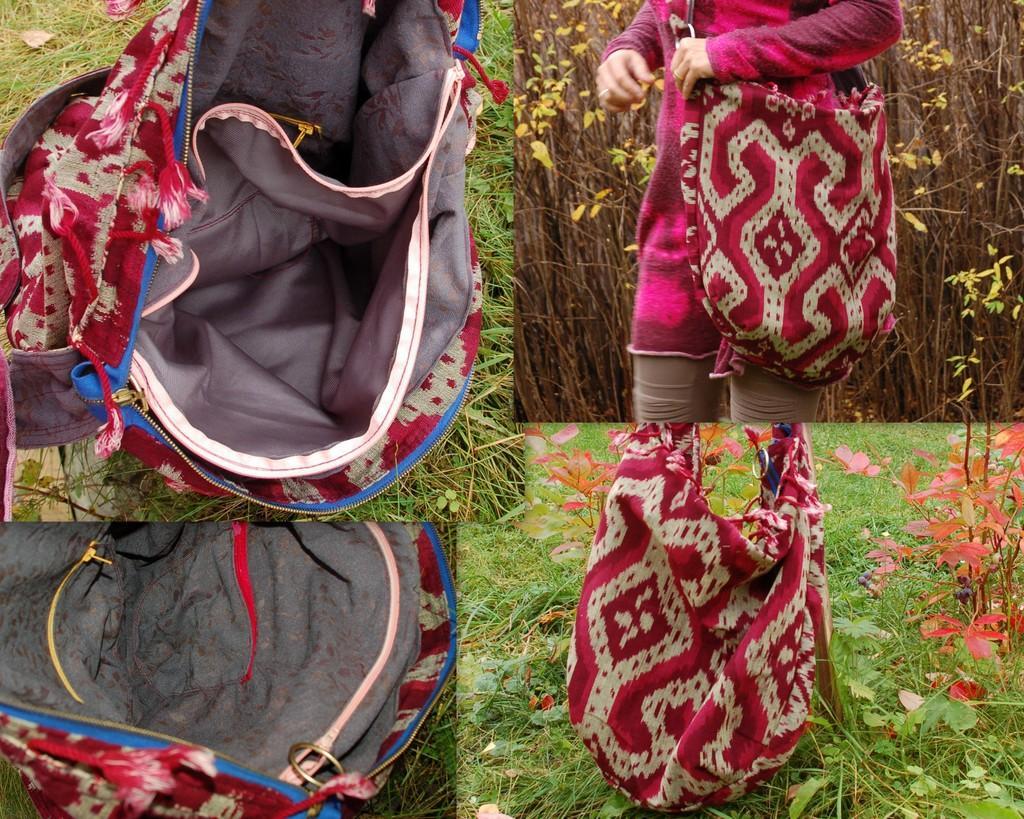Could you give a brief overview of what you see in this image? This is a collage image and in the right side we can see a person having a handbag and at the bottom right we can see only handbag placed on grass and at the top left we can see handbag and the bottom left also we can see handbag opened 